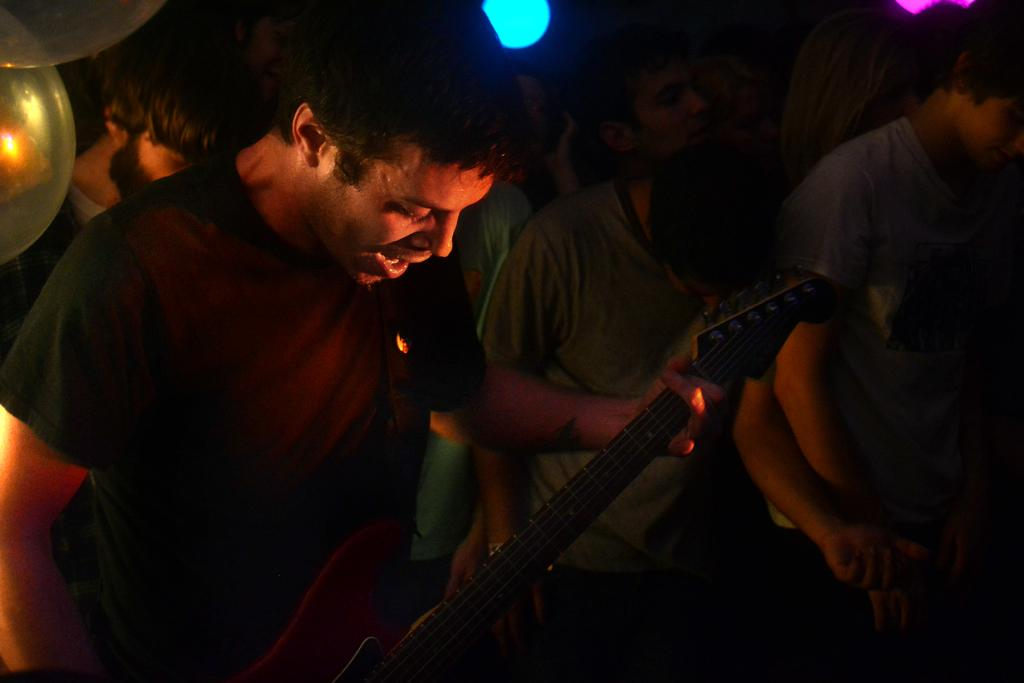What is the person in the image doing? The person is standing in the image and holding a guitar in his hand. How many people are present in the image? There are multiple people standing in the image. What type of juice is being served by the governor in the image? There is no governor or juice present in the image. 